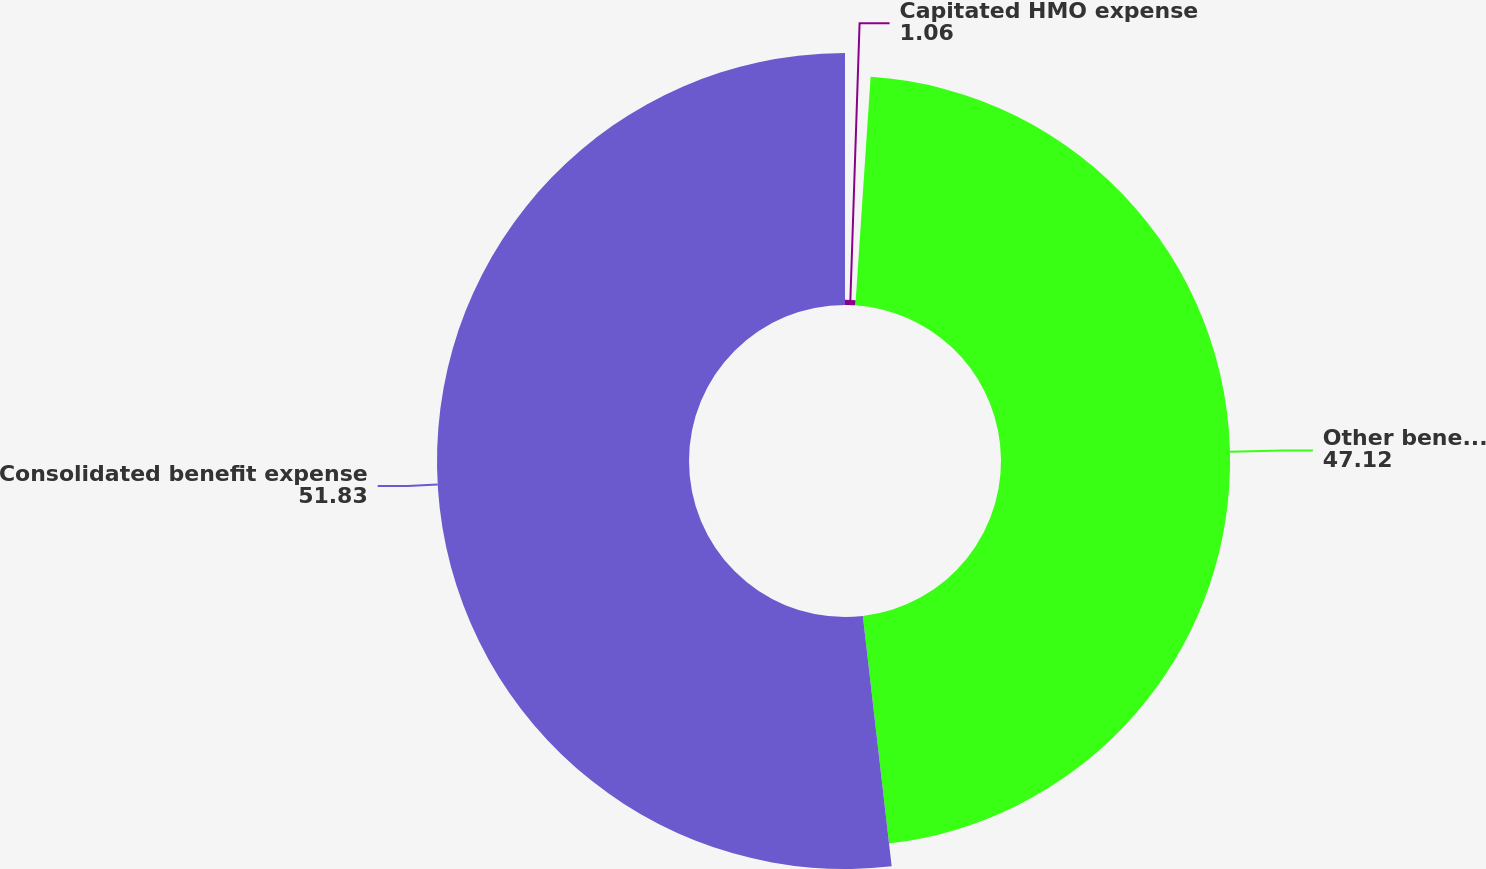Convert chart. <chart><loc_0><loc_0><loc_500><loc_500><pie_chart><fcel>Capitated HMO expense<fcel>Other benefit expense<fcel>Consolidated benefit expense<nl><fcel>1.06%<fcel>47.12%<fcel>51.83%<nl></chart> 